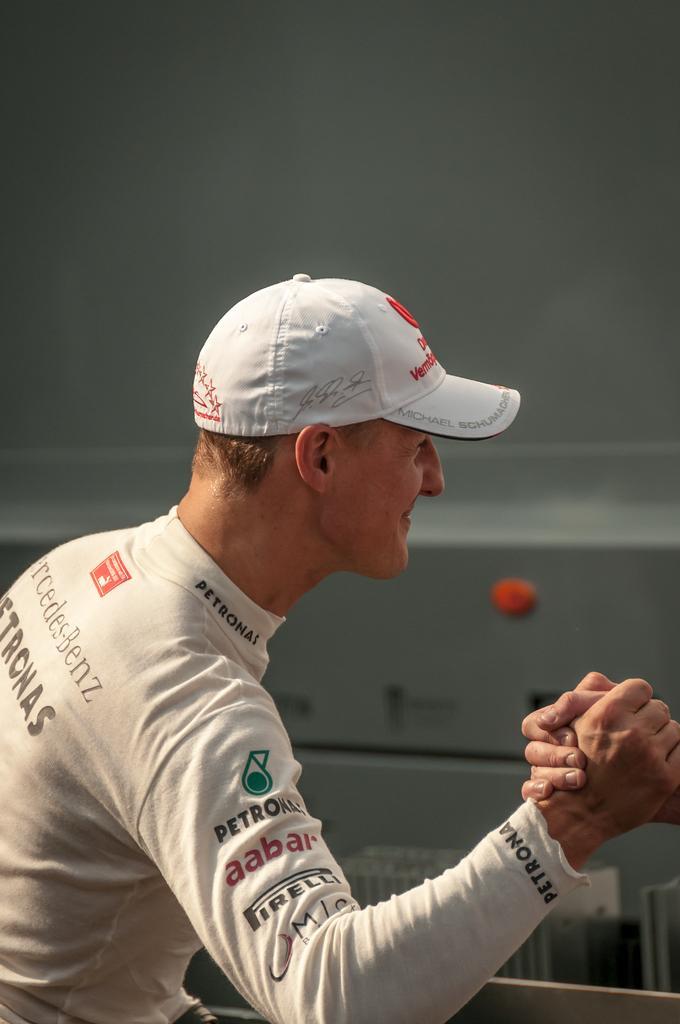Please provide a concise description of this image. In the middle of the image there is a man holding the hand of another person. In the background there is a wall. At the top of the image there is a roof. 